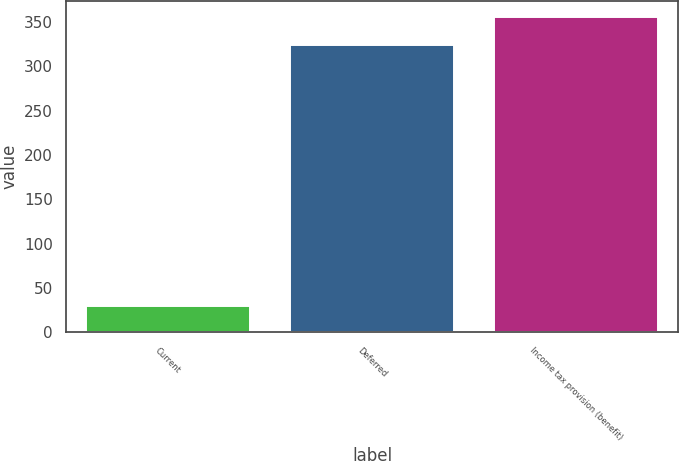Convert chart. <chart><loc_0><loc_0><loc_500><loc_500><bar_chart><fcel>Current<fcel>Deferred<fcel>Income tax provision (benefit)<nl><fcel>30<fcel>324<fcel>356.4<nl></chart> 